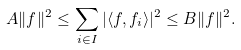Convert formula to latex. <formula><loc_0><loc_0><loc_500><loc_500>A \| f \| ^ { 2 } \leq \sum _ { i \in I } | \langle f , f _ { i } \rangle | ^ { 2 } \leq B \| f \| ^ { 2 } .</formula> 